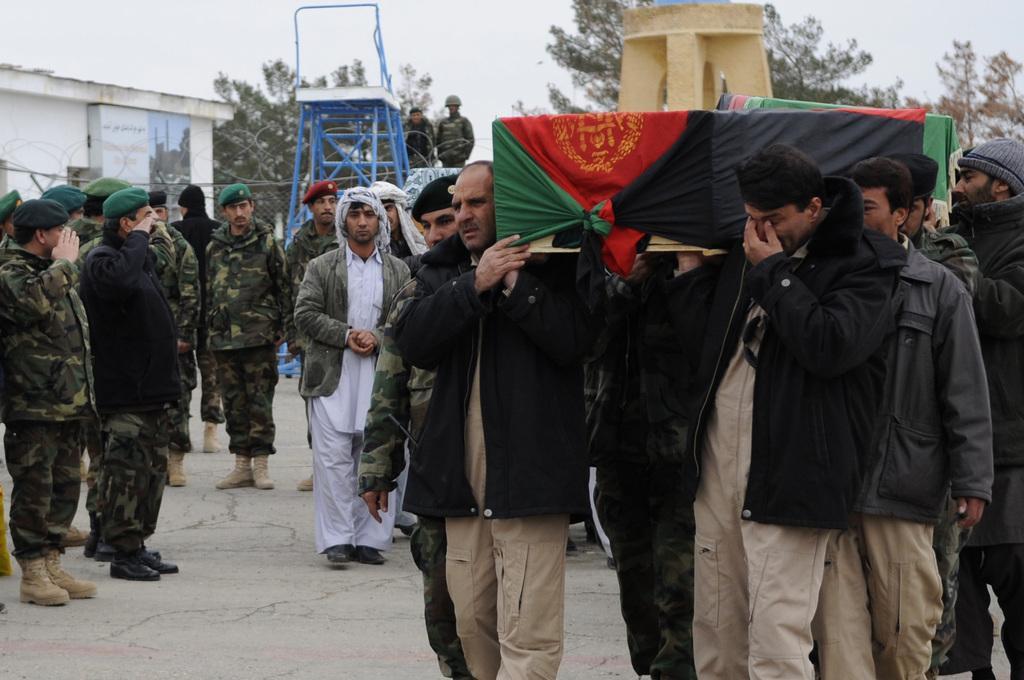Describe this image in one or two sentences. Here in this picture we can see number of people standing and walking on the ground over there and some people are wearing military dress on them and wearing caps on them and saluting and on the right side we can see some people carrying a casket on their shoulders and we can see flag covered on it over there and behind them we can see a ladder present and we can see trees present all over there and we can also see a fencing present over there. 